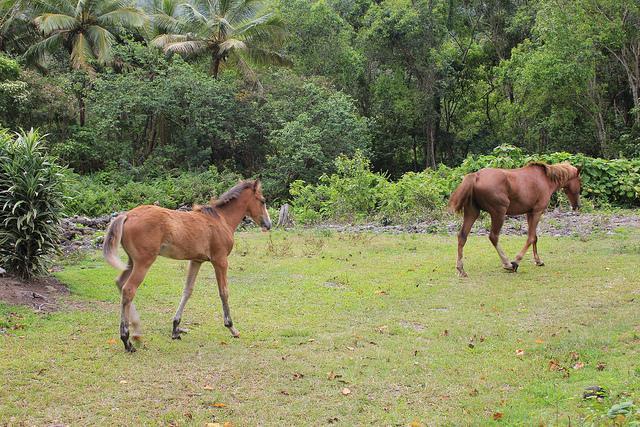How many horses are adults in this image?
Give a very brief answer. 2. How many horses are grazing?
Give a very brief answer. 2. How many animals are shown?
Give a very brief answer. 2. How many horses are in the photo?
Give a very brief answer. 2. 